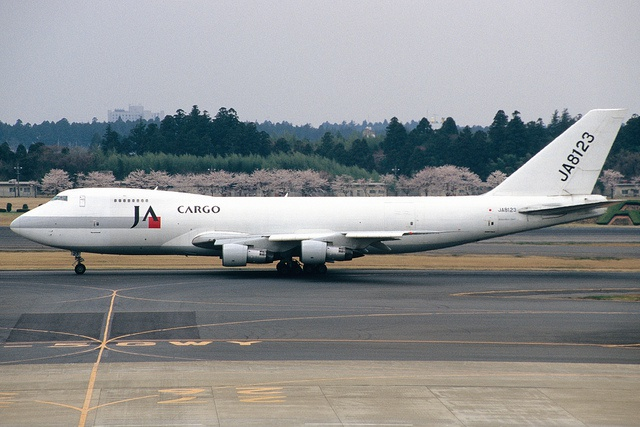Describe the objects in this image and their specific colors. I can see a airplane in darkgray, lightgray, black, and gray tones in this image. 